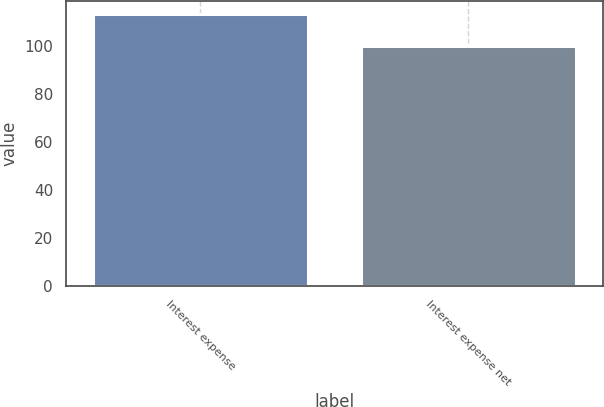<chart> <loc_0><loc_0><loc_500><loc_500><bar_chart><fcel>Interest expense<fcel>Interest expense net<nl><fcel>113<fcel>100<nl></chart> 